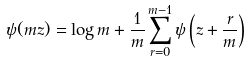<formula> <loc_0><loc_0><loc_500><loc_500>\psi ( m z ) = \log m + \frac { 1 } { m } \sum _ { r = 0 } ^ { m - 1 } \psi \left ( z + \frac { r } { m } \right )</formula> 